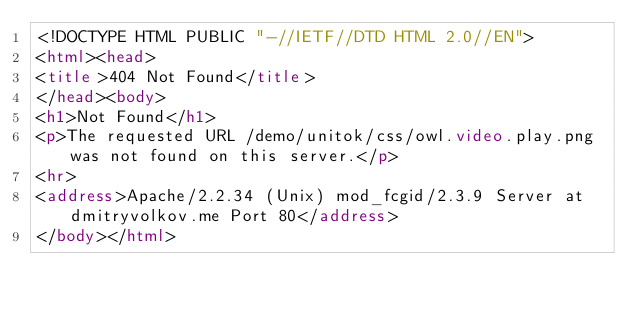<code> <loc_0><loc_0><loc_500><loc_500><_HTML_><!DOCTYPE HTML PUBLIC "-//IETF//DTD HTML 2.0//EN">
<html><head>
<title>404 Not Found</title>
</head><body>
<h1>Not Found</h1>
<p>The requested URL /demo/unitok/css/owl.video.play.png was not found on this server.</p>
<hr>
<address>Apache/2.2.34 (Unix) mod_fcgid/2.3.9 Server at dmitryvolkov.me Port 80</address>
</body></html>
</code> 